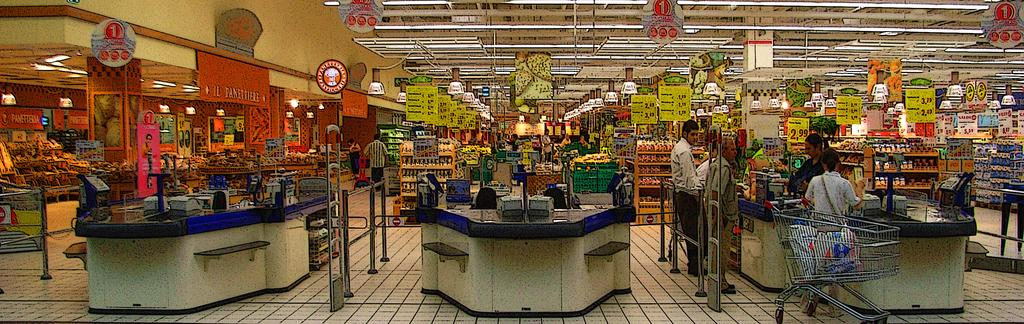<image>
Give a short and clear explanation of the subsequent image. A view of a large grocery store with many signs including one that reads 2.99. 